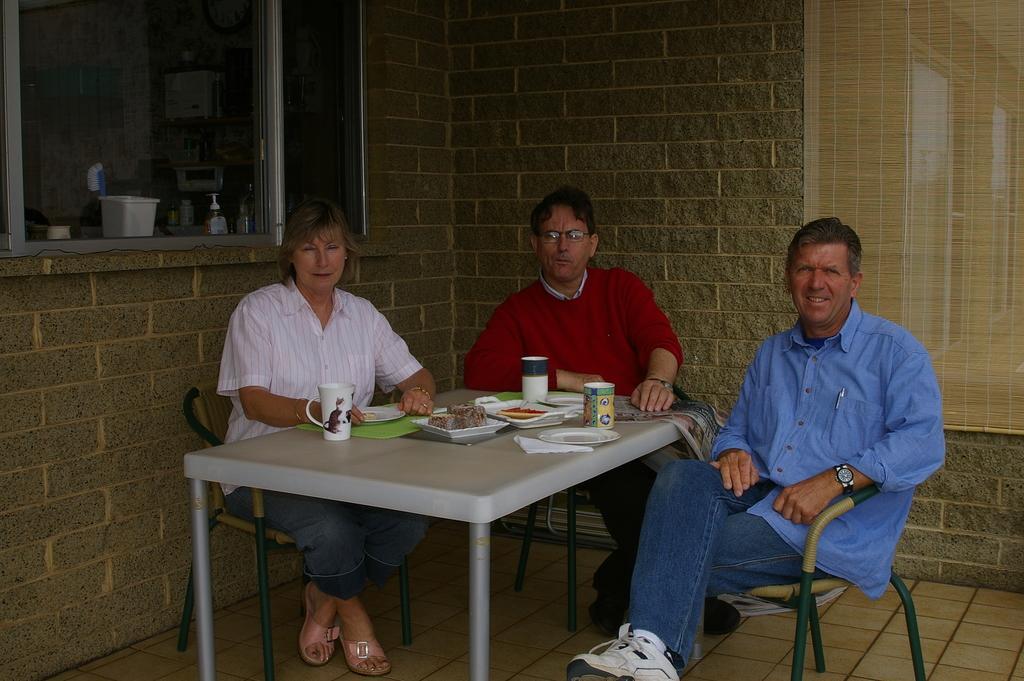How would you summarize this image in a sentence or two? In this picture we can see two men and one woman sitting on chair and in front of them there is table and on table we can see cup, plate, some food items, paper and in background we can see wall, window and from window we can see bucket, brush, hand wash bottle, watch. 